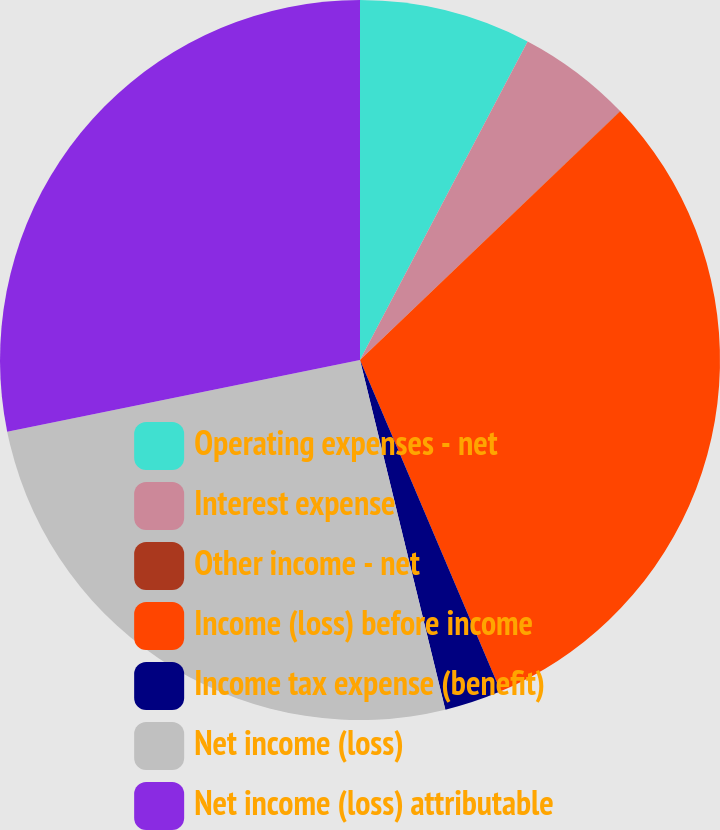<chart> <loc_0><loc_0><loc_500><loc_500><pie_chart><fcel>Operating expenses - net<fcel>Interest expense<fcel>Other income - net<fcel>Income (loss) before income<fcel>Income tax expense (benefit)<fcel>Net income (loss)<fcel>Net income (loss) attributable<nl><fcel>7.71%<fcel>5.14%<fcel>0.01%<fcel>30.75%<fcel>2.58%<fcel>25.62%<fcel>28.19%<nl></chart> 